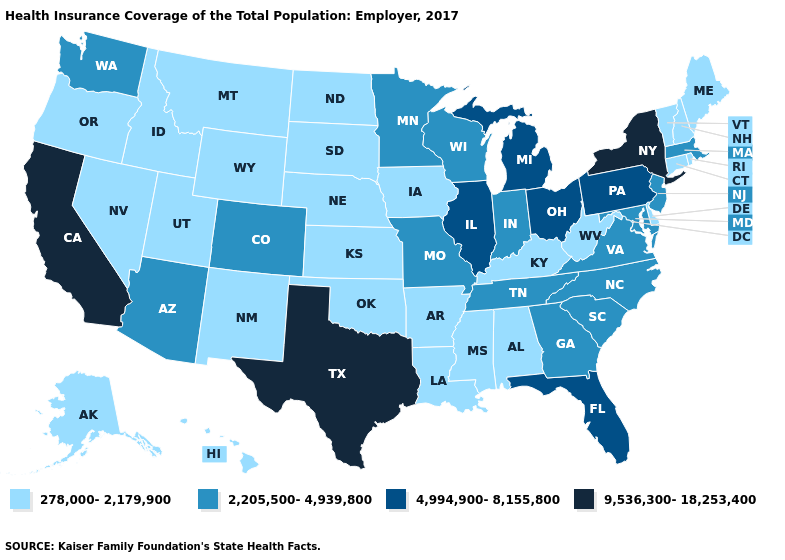Name the states that have a value in the range 2,205,500-4,939,800?
Quick response, please. Arizona, Colorado, Georgia, Indiana, Maryland, Massachusetts, Minnesota, Missouri, New Jersey, North Carolina, South Carolina, Tennessee, Virginia, Washington, Wisconsin. What is the value of Iowa?
Give a very brief answer. 278,000-2,179,900. What is the value of Minnesota?
Give a very brief answer. 2,205,500-4,939,800. Name the states that have a value in the range 9,536,300-18,253,400?
Give a very brief answer. California, New York, Texas. Does Maryland have the same value as South Dakota?
Answer briefly. No. Among the states that border Arkansas , does Mississippi have the highest value?
Concise answer only. No. What is the lowest value in states that border West Virginia?
Keep it brief. 278,000-2,179,900. What is the value of Arkansas?
Keep it brief. 278,000-2,179,900. Which states have the highest value in the USA?
Be succinct. California, New York, Texas. Name the states that have a value in the range 278,000-2,179,900?
Write a very short answer. Alabama, Alaska, Arkansas, Connecticut, Delaware, Hawaii, Idaho, Iowa, Kansas, Kentucky, Louisiana, Maine, Mississippi, Montana, Nebraska, Nevada, New Hampshire, New Mexico, North Dakota, Oklahoma, Oregon, Rhode Island, South Dakota, Utah, Vermont, West Virginia, Wyoming. Name the states that have a value in the range 2,205,500-4,939,800?
Short answer required. Arizona, Colorado, Georgia, Indiana, Maryland, Massachusetts, Minnesota, Missouri, New Jersey, North Carolina, South Carolina, Tennessee, Virginia, Washington, Wisconsin. Does Alaska have a lower value than Wyoming?
Answer briefly. No. Does the first symbol in the legend represent the smallest category?
Concise answer only. Yes. What is the value of North Dakota?
Give a very brief answer. 278,000-2,179,900. Does Colorado have the lowest value in the USA?
Quick response, please. No. 